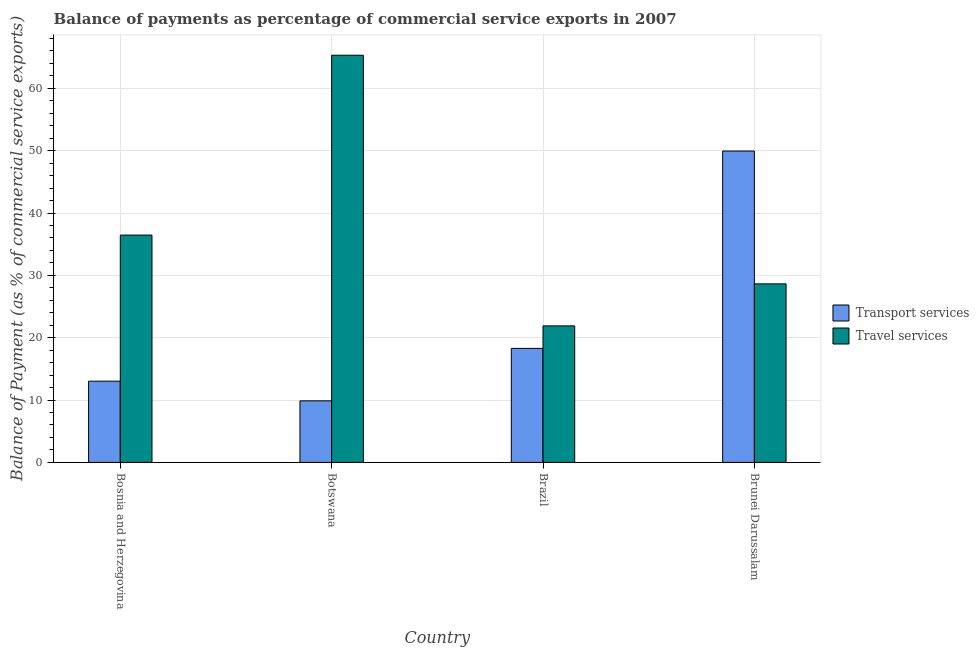How many different coloured bars are there?
Your answer should be very brief. 2. Are the number of bars per tick equal to the number of legend labels?
Offer a terse response. Yes. Are the number of bars on each tick of the X-axis equal?
Your answer should be very brief. Yes. What is the label of the 2nd group of bars from the left?
Ensure brevity in your answer.  Botswana. In how many cases, is the number of bars for a given country not equal to the number of legend labels?
Your answer should be very brief. 0. What is the balance of payments of transport services in Brunei Darussalam?
Your answer should be very brief. 49.95. Across all countries, what is the maximum balance of payments of travel services?
Your response must be concise. 65.32. Across all countries, what is the minimum balance of payments of transport services?
Your answer should be very brief. 9.88. In which country was the balance of payments of transport services maximum?
Your answer should be very brief. Brunei Darussalam. In which country was the balance of payments of transport services minimum?
Keep it short and to the point. Botswana. What is the total balance of payments of transport services in the graph?
Offer a terse response. 91.15. What is the difference between the balance of payments of transport services in Botswana and that in Brunei Darussalam?
Your answer should be compact. -40.07. What is the difference between the balance of payments of transport services in Brunei Darussalam and the balance of payments of travel services in Brazil?
Make the answer very short. 28.05. What is the average balance of payments of travel services per country?
Your answer should be compact. 38.08. What is the difference between the balance of payments of transport services and balance of payments of travel services in Botswana?
Offer a terse response. -55.44. What is the ratio of the balance of payments of transport services in Bosnia and Herzegovina to that in Botswana?
Keep it short and to the point. 1.32. Is the balance of payments of transport services in Bosnia and Herzegovina less than that in Brunei Darussalam?
Give a very brief answer. Yes. Is the difference between the balance of payments of travel services in Bosnia and Herzegovina and Brunei Darussalam greater than the difference between the balance of payments of transport services in Bosnia and Herzegovina and Brunei Darussalam?
Make the answer very short. Yes. What is the difference between the highest and the second highest balance of payments of travel services?
Ensure brevity in your answer.  28.85. What is the difference between the highest and the lowest balance of payments of transport services?
Provide a succinct answer. 40.07. In how many countries, is the balance of payments of travel services greater than the average balance of payments of travel services taken over all countries?
Offer a terse response. 1. What does the 1st bar from the left in Bosnia and Herzegovina represents?
Your answer should be very brief. Transport services. What does the 2nd bar from the right in Brazil represents?
Ensure brevity in your answer.  Transport services. What is the difference between two consecutive major ticks on the Y-axis?
Keep it short and to the point. 10. Does the graph contain any zero values?
Your answer should be very brief. No. Does the graph contain grids?
Provide a succinct answer. Yes. How many legend labels are there?
Your answer should be compact. 2. What is the title of the graph?
Your answer should be very brief. Balance of payments as percentage of commercial service exports in 2007. Does "GDP" appear as one of the legend labels in the graph?
Your response must be concise. No. What is the label or title of the Y-axis?
Keep it short and to the point. Balance of Payment (as % of commercial service exports). What is the Balance of Payment (as % of commercial service exports) of Transport services in Bosnia and Herzegovina?
Your answer should be very brief. 13.03. What is the Balance of Payment (as % of commercial service exports) of Travel services in Bosnia and Herzegovina?
Your answer should be compact. 36.47. What is the Balance of Payment (as % of commercial service exports) of Transport services in Botswana?
Your response must be concise. 9.88. What is the Balance of Payment (as % of commercial service exports) of Travel services in Botswana?
Make the answer very short. 65.32. What is the Balance of Payment (as % of commercial service exports) of Transport services in Brazil?
Ensure brevity in your answer.  18.29. What is the Balance of Payment (as % of commercial service exports) in Travel services in Brazil?
Give a very brief answer. 21.9. What is the Balance of Payment (as % of commercial service exports) in Transport services in Brunei Darussalam?
Your response must be concise. 49.95. What is the Balance of Payment (as % of commercial service exports) of Travel services in Brunei Darussalam?
Your response must be concise. 28.64. Across all countries, what is the maximum Balance of Payment (as % of commercial service exports) of Transport services?
Your response must be concise. 49.95. Across all countries, what is the maximum Balance of Payment (as % of commercial service exports) of Travel services?
Your answer should be very brief. 65.32. Across all countries, what is the minimum Balance of Payment (as % of commercial service exports) in Transport services?
Keep it short and to the point. 9.88. Across all countries, what is the minimum Balance of Payment (as % of commercial service exports) of Travel services?
Provide a succinct answer. 21.9. What is the total Balance of Payment (as % of commercial service exports) in Transport services in the graph?
Make the answer very short. 91.15. What is the total Balance of Payment (as % of commercial service exports) in Travel services in the graph?
Keep it short and to the point. 152.33. What is the difference between the Balance of Payment (as % of commercial service exports) of Transport services in Bosnia and Herzegovina and that in Botswana?
Provide a short and direct response. 3.15. What is the difference between the Balance of Payment (as % of commercial service exports) of Travel services in Bosnia and Herzegovina and that in Botswana?
Keep it short and to the point. -28.85. What is the difference between the Balance of Payment (as % of commercial service exports) in Transport services in Bosnia and Herzegovina and that in Brazil?
Offer a very short reply. -5.26. What is the difference between the Balance of Payment (as % of commercial service exports) in Travel services in Bosnia and Herzegovina and that in Brazil?
Provide a succinct answer. 14.57. What is the difference between the Balance of Payment (as % of commercial service exports) of Transport services in Bosnia and Herzegovina and that in Brunei Darussalam?
Your response must be concise. -36.92. What is the difference between the Balance of Payment (as % of commercial service exports) in Travel services in Bosnia and Herzegovina and that in Brunei Darussalam?
Your answer should be very brief. 7.83. What is the difference between the Balance of Payment (as % of commercial service exports) in Transport services in Botswana and that in Brazil?
Offer a terse response. -8.42. What is the difference between the Balance of Payment (as % of commercial service exports) of Travel services in Botswana and that in Brazil?
Make the answer very short. 43.42. What is the difference between the Balance of Payment (as % of commercial service exports) in Transport services in Botswana and that in Brunei Darussalam?
Ensure brevity in your answer.  -40.07. What is the difference between the Balance of Payment (as % of commercial service exports) in Travel services in Botswana and that in Brunei Darussalam?
Make the answer very short. 36.68. What is the difference between the Balance of Payment (as % of commercial service exports) of Transport services in Brazil and that in Brunei Darussalam?
Keep it short and to the point. -31.66. What is the difference between the Balance of Payment (as % of commercial service exports) in Travel services in Brazil and that in Brunei Darussalam?
Give a very brief answer. -6.74. What is the difference between the Balance of Payment (as % of commercial service exports) in Transport services in Bosnia and Herzegovina and the Balance of Payment (as % of commercial service exports) in Travel services in Botswana?
Make the answer very short. -52.29. What is the difference between the Balance of Payment (as % of commercial service exports) of Transport services in Bosnia and Herzegovina and the Balance of Payment (as % of commercial service exports) of Travel services in Brazil?
Keep it short and to the point. -8.87. What is the difference between the Balance of Payment (as % of commercial service exports) of Transport services in Bosnia and Herzegovina and the Balance of Payment (as % of commercial service exports) of Travel services in Brunei Darussalam?
Provide a succinct answer. -15.61. What is the difference between the Balance of Payment (as % of commercial service exports) in Transport services in Botswana and the Balance of Payment (as % of commercial service exports) in Travel services in Brazil?
Offer a terse response. -12.03. What is the difference between the Balance of Payment (as % of commercial service exports) in Transport services in Botswana and the Balance of Payment (as % of commercial service exports) in Travel services in Brunei Darussalam?
Your response must be concise. -18.76. What is the difference between the Balance of Payment (as % of commercial service exports) of Transport services in Brazil and the Balance of Payment (as % of commercial service exports) of Travel services in Brunei Darussalam?
Ensure brevity in your answer.  -10.35. What is the average Balance of Payment (as % of commercial service exports) in Transport services per country?
Provide a succinct answer. 22.79. What is the average Balance of Payment (as % of commercial service exports) in Travel services per country?
Offer a very short reply. 38.08. What is the difference between the Balance of Payment (as % of commercial service exports) of Transport services and Balance of Payment (as % of commercial service exports) of Travel services in Bosnia and Herzegovina?
Your answer should be very brief. -23.44. What is the difference between the Balance of Payment (as % of commercial service exports) of Transport services and Balance of Payment (as % of commercial service exports) of Travel services in Botswana?
Provide a succinct answer. -55.44. What is the difference between the Balance of Payment (as % of commercial service exports) of Transport services and Balance of Payment (as % of commercial service exports) of Travel services in Brazil?
Your answer should be compact. -3.61. What is the difference between the Balance of Payment (as % of commercial service exports) of Transport services and Balance of Payment (as % of commercial service exports) of Travel services in Brunei Darussalam?
Give a very brief answer. 21.31. What is the ratio of the Balance of Payment (as % of commercial service exports) in Transport services in Bosnia and Herzegovina to that in Botswana?
Make the answer very short. 1.32. What is the ratio of the Balance of Payment (as % of commercial service exports) in Travel services in Bosnia and Herzegovina to that in Botswana?
Offer a very short reply. 0.56. What is the ratio of the Balance of Payment (as % of commercial service exports) of Transport services in Bosnia and Herzegovina to that in Brazil?
Keep it short and to the point. 0.71. What is the ratio of the Balance of Payment (as % of commercial service exports) of Travel services in Bosnia and Herzegovina to that in Brazil?
Your answer should be very brief. 1.67. What is the ratio of the Balance of Payment (as % of commercial service exports) in Transport services in Bosnia and Herzegovina to that in Brunei Darussalam?
Provide a succinct answer. 0.26. What is the ratio of the Balance of Payment (as % of commercial service exports) of Travel services in Bosnia and Herzegovina to that in Brunei Darussalam?
Offer a very short reply. 1.27. What is the ratio of the Balance of Payment (as % of commercial service exports) of Transport services in Botswana to that in Brazil?
Ensure brevity in your answer.  0.54. What is the ratio of the Balance of Payment (as % of commercial service exports) of Travel services in Botswana to that in Brazil?
Provide a short and direct response. 2.98. What is the ratio of the Balance of Payment (as % of commercial service exports) of Transport services in Botswana to that in Brunei Darussalam?
Give a very brief answer. 0.2. What is the ratio of the Balance of Payment (as % of commercial service exports) of Travel services in Botswana to that in Brunei Darussalam?
Keep it short and to the point. 2.28. What is the ratio of the Balance of Payment (as % of commercial service exports) of Transport services in Brazil to that in Brunei Darussalam?
Ensure brevity in your answer.  0.37. What is the ratio of the Balance of Payment (as % of commercial service exports) of Travel services in Brazil to that in Brunei Darussalam?
Offer a very short reply. 0.76. What is the difference between the highest and the second highest Balance of Payment (as % of commercial service exports) of Transport services?
Your answer should be very brief. 31.66. What is the difference between the highest and the second highest Balance of Payment (as % of commercial service exports) in Travel services?
Give a very brief answer. 28.85. What is the difference between the highest and the lowest Balance of Payment (as % of commercial service exports) of Transport services?
Your answer should be compact. 40.07. What is the difference between the highest and the lowest Balance of Payment (as % of commercial service exports) in Travel services?
Your answer should be very brief. 43.42. 